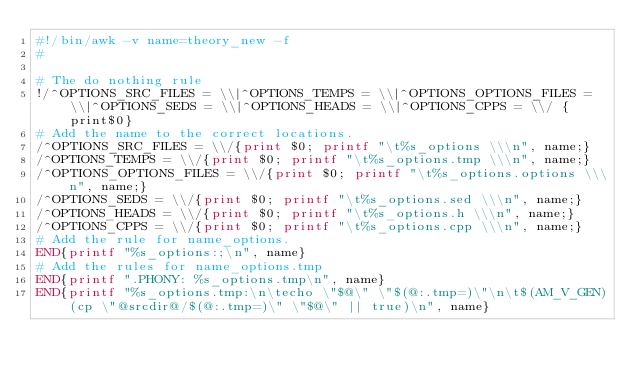<code> <loc_0><loc_0><loc_500><loc_500><_Awk_>#!/bin/awk -v name=theory_new -f
#

# The do nothing rule
!/^OPTIONS_SRC_FILES = \\|^OPTIONS_TEMPS = \\|^OPTIONS_OPTIONS_FILES = \\|^OPTIONS_SEDS = \\|^OPTIONS_HEADS = \\|^OPTIONS_CPPS = \\/ {print$0}
# Add the name to the correct locations.
/^OPTIONS_SRC_FILES = \\/{print $0; printf "\t%s_options \\\n", name;}
/^OPTIONS_TEMPS = \\/{print $0; printf "\t%s_options.tmp \\\n", name;}
/^OPTIONS_OPTIONS_FILES = \\/{print $0; printf "\t%s_options.options \\\n", name;}
/^OPTIONS_SEDS = \\/{print $0; printf "\t%s_options.sed \\\n", name;}
/^OPTIONS_HEADS = \\/{print $0; printf "\t%s_options.h \\\n", name;}
/^OPTIONS_CPPS = \\/{print $0; printf "\t%s_options.cpp \\\n", name;}
# Add the rule for name_options.
END{printf "%s_options:;\n", name}
# Add the rules for name_options.tmp
END{printf ".PHONY: %s_options.tmp\n", name}
END{printf "%s_options.tmp:\n\techo \"$@\" \"$(@:.tmp=)\"\n\t$(AM_V_GEN)(cp \"@srcdir@/$(@:.tmp=)\" \"$@\" || true)\n", name}
</code> 